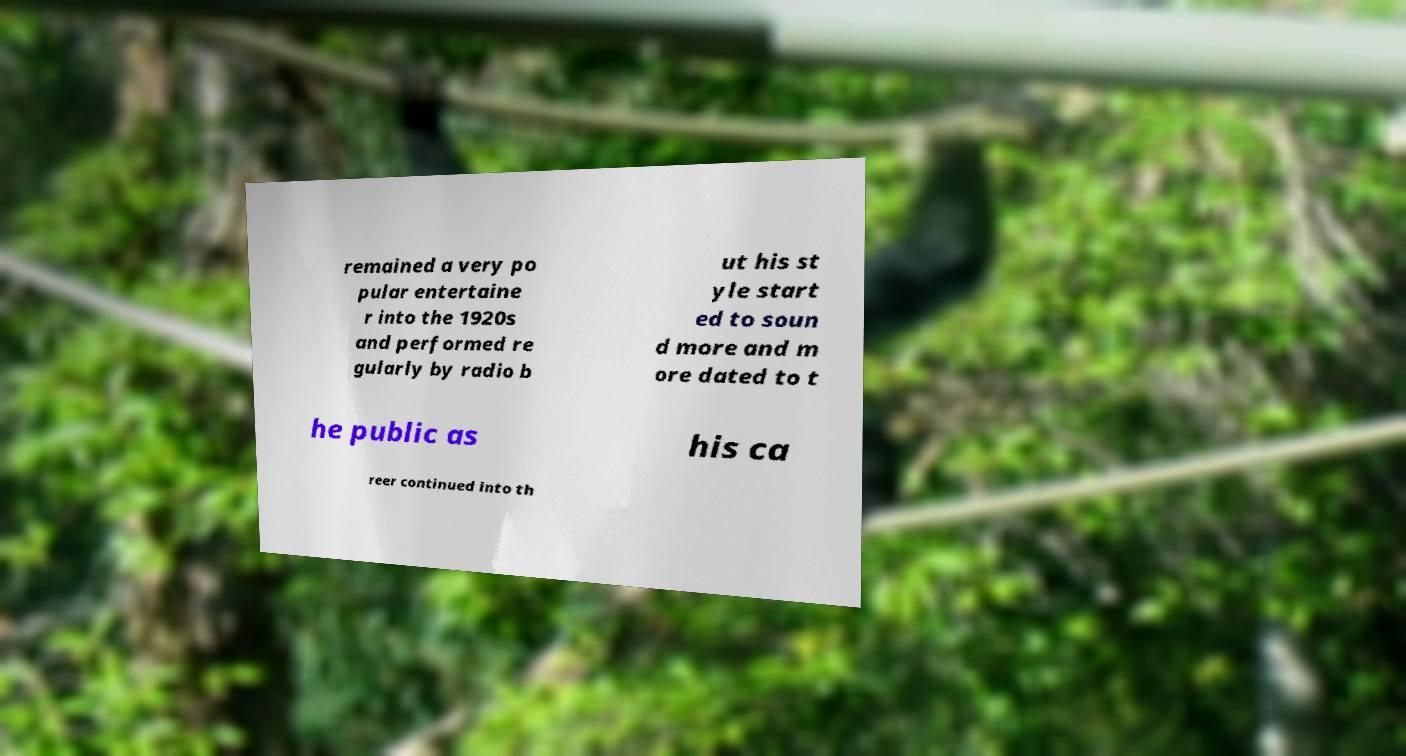What messages or text are displayed in this image? I need them in a readable, typed format. remained a very po pular entertaine r into the 1920s and performed re gularly by radio b ut his st yle start ed to soun d more and m ore dated to t he public as his ca reer continued into th 